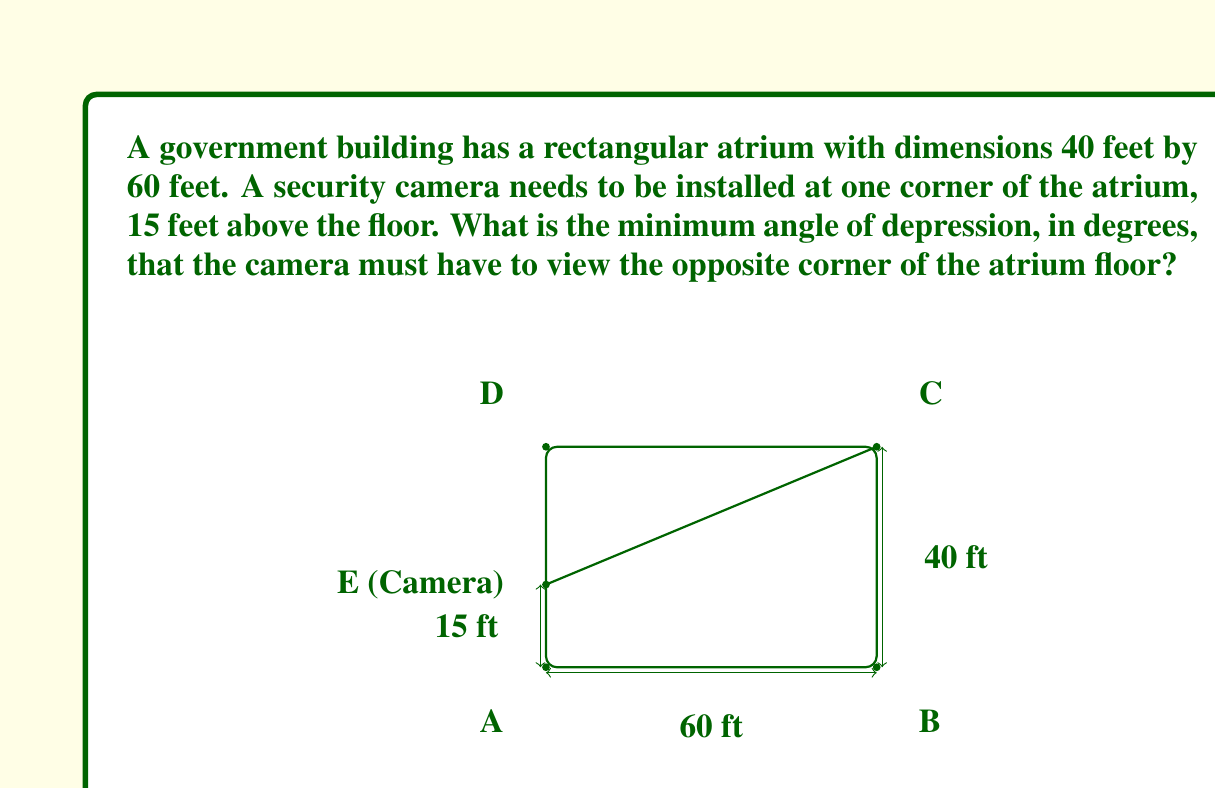What is the answer to this math problem? To solve this problem, we'll use trigonometry to find the angle of depression. Let's break it down step-by-step:

1) First, we need to find the distance from the camera to the opposite corner on the floor. This forms the hypotenuse of a right triangle.

2) The base of this triangle is the diagonal of the atrium floor. We can calculate this using the Pythagorean theorem:

   $$\text{diagonal} = \sqrt{40^2 + 60^2} = \sqrt{1600 + 3600} = \sqrt{5200} = 20\sqrt{13} \text{ feet}$$

3) Now we have a right triangle with:
   - Height = 15 feet (camera height)
   - Base = $20\sqrt{13}$ feet (atrium diagonal)

4) To find the angle of depression, we need to calculate the inverse tangent of the height divided by the base:

   $$\theta = \tan^{-1}\left(\frac{\text{opposite}}{\text{adjacent}}\right) = \tan^{-1}\left(\frac{15}{20\sqrt{13}}\right)$$

5) Simplifying inside the inverse tangent:

   $$\theta = \tan^{-1}\left(\frac{15}{20\sqrt{13}}\right) = \tan^{-1}\left(\frac{3}{4\sqrt{13}}\right)$$

6) Using a calculator or computer to evaluate this:

   $$\theta \approx 11.31^\circ$$

Therefore, the minimum angle of depression for the camera is approximately 11.31 degrees.
Answer: $11.31^\circ$ 